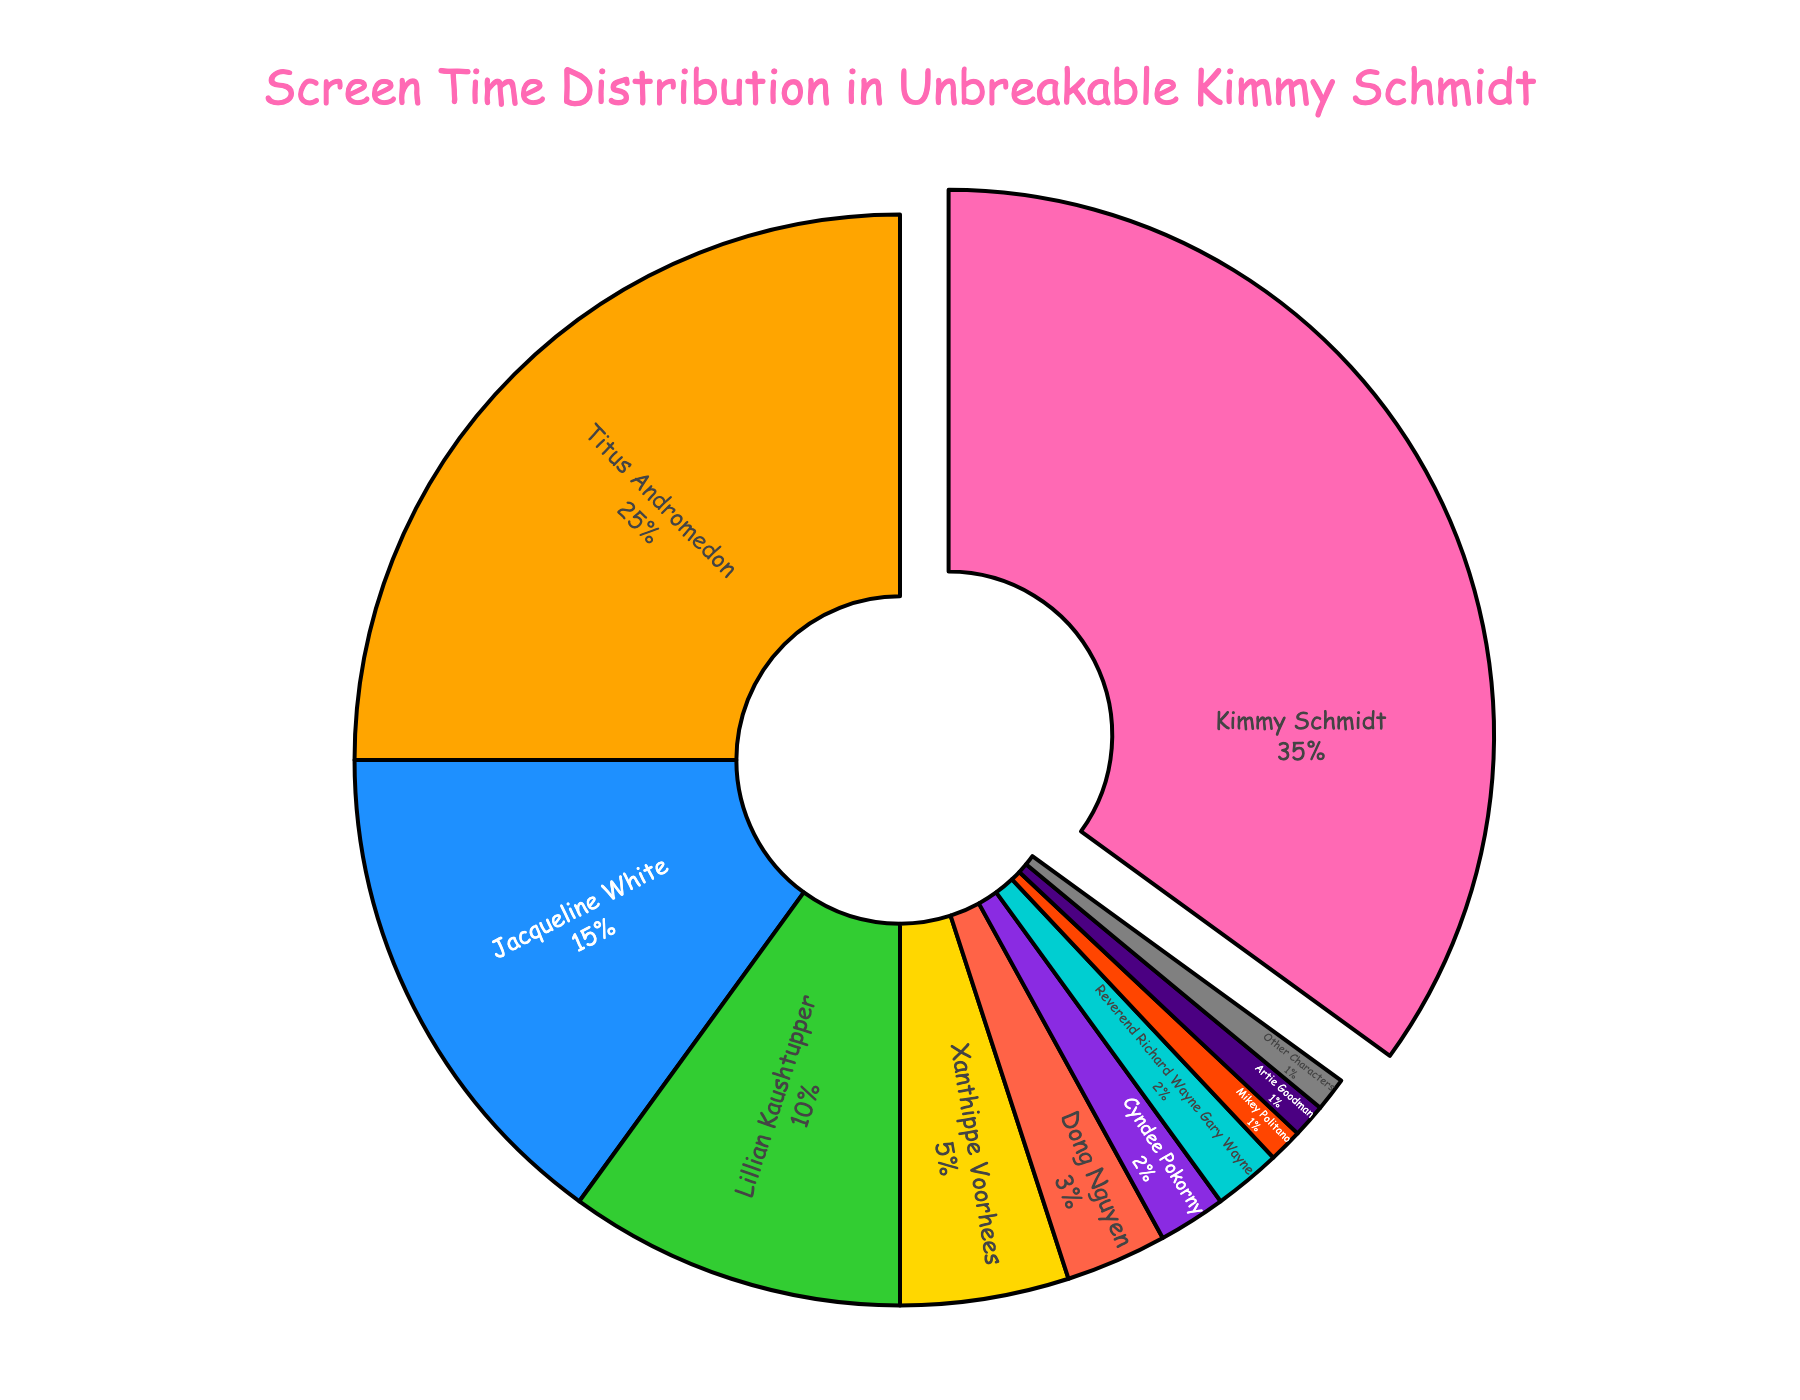What's the total screen time percentage for Kimmy Schmidt and Titus Andromedon? To find the total screen time percentage for both Kimmy Schmidt and Titus Andromedon, sum their individual screen time percentages. Kimmy Schmidt has 35% and Titus Andromedon has 25%. Therefore, the combined total is 35% + 25% = 60%.
Answer: 60% Who has more screen time, Jacqueline White or Lillian Kaushtupper? Comparing the screen time percentages, Jacqueline White has 15% while Lillian Kaushtupper has 10%. Since 15% is greater than 10%, Jacqueline White has more screen time.
Answer: Jacqueline White What is the percentage difference in screen time between Xanthippe Voorhees and Dong Nguyen? Xanthippe Voorhees has a screen time percentage of 5% while Dong Nguyen has 3%. The difference is found by subtracting the smaller percentage from the larger one: 5% - 3% = 2%.
Answer: 2% Which character's screen time is closest to 1%? By observing the pie chart, Mikey Politano, Artie Goodman, and Other Characters each have exactly 1% screen time. Hence, their screen times are all closest to 1%.
Answer: Mikey Politano, Artie Goodman, and Other Characters How many characters have a screen time of less than 5%? From the figure, Cyndee Pokorny, Reverend Richard Wayne Gary Wayne, Mikey Politano, Artie Goodman, and Other Characters all have screen times less than 5%. Counting these, we get 1, 2, 3, 4, and 5 respectively.
Answer: 5 What's the average screen time percentage for Lillian Kaushtupper, Xanthippe Voorhees, and Dong Nguyen? To find the average, sum the screen times for the three characters and then divide by the number of characters: (10 + 5 + 3) / 3 = 18 / 3 = 6%.
Answer: 6% Who has the highest screen time among the characters, and what is it? The character with the highest screen time in the pie chart is Kimmy Schmidt. Her screen time percentage is 35%.
Answer: Kimmy Schmidt, 35% Which character's screen time is visually emphasized in the pie chart? Kimmy Schmidt's portion of the pie chart is visually emphasized by being slightly pulled out from the chart.
Answer: Kimmy Schmidt 